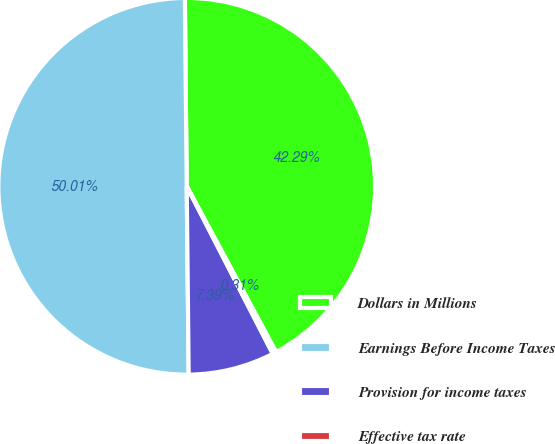Convert chart to OTSL. <chart><loc_0><loc_0><loc_500><loc_500><pie_chart><fcel>Dollars in Millions<fcel>Earnings Before Income Taxes<fcel>Provision for income taxes<fcel>Effective tax rate<nl><fcel>42.29%<fcel>50.0%<fcel>7.39%<fcel>0.31%<nl></chart> 